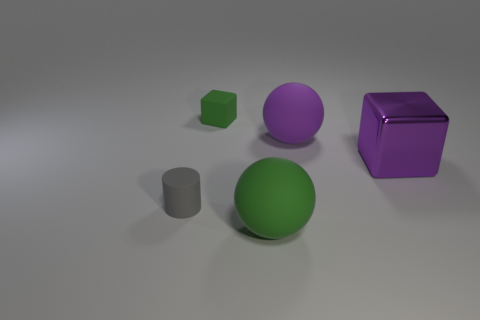What size is the purple sphere?
Keep it short and to the point. Large. How big is the green rubber object in front of the tiny gray rubber cylinder?
Keep it short and to the point. Large. There is a big thing that is both behind the gray matte object and in front of the purple ball; what shape is it?
Provide a succinct answer. Cube. What number of other objects are there of the same shape as the large green rubber thing?
Keep it short and to the point. 1. There is another rubber ball that is the same size as the purple sphere; what is its color?
Ensure brevity in your answer.  Green. How many things are either purple objects or small green objects?
Make the answer very short. 3. There is a purple shiny thing; are there any big shiny cubes on the right side of it?
Provide a succinct answer. No. Is there a large green block that has the same material as the tiny gray cylinder?
Provide a short and direct response. No. The ball that is the same color as the shiny block is what size?
Your answer should be very brief. Large. How many blocks are either big things or tiny gray things?
Offer a terse response. 1. 